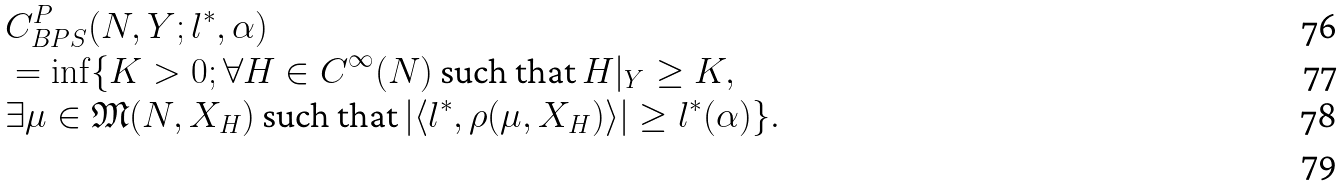<formula> <loc_0><loc_0><loc_500><loc_500>& C _ { B P S } ^ { P } ( N , Y ; l ^ { \ast } , \alpha ) \\ & = \inf \{ K > 0 ; \forall H \in C ^ { \infty } ( N ) \text { such that } H | _ { Y } \geq K , \\ & \exists \mu \in \mathfrak { M } ( N , X _ { H } ) \text { such that } | \langle l ^ { \ast } , \rho ( \mu , X _ { H } ) \rangle | \geq l ^ { \ast } ( \alpha ) \} . \\</formula> 